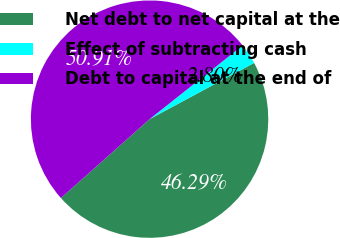Convert chart to OTSL. <chart><loc_0><loc_0><loc_500><loc_500><pie_chart><fcel>Net debt to net capital at the<fcel>Effect of subtracting cash<fcel>Debt to capital at the end of<nl><fcel>46.29%<fcel>2.8%<fcel>50.92%<nl></chart> 